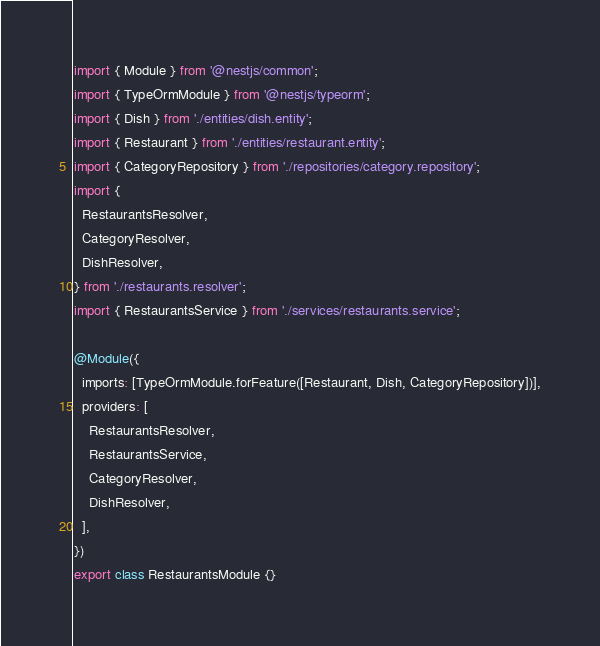<code> <loc_0><loc_0><loc_500><loc_500><_TypeScript_>import { Module } from '@nestjs/common';
import { TypeOrmModule } from '@nestjs/typeorm';
import { Dish } from './entities/dish.entity';
import { Restaurant } from './entities/restaurant.entity';
import { CategoryRepository } from './repositories/category.repository';
import {
  RestaurantsResolver,
  CategoryResolver,
  DishResolver,
} from './restaurants.resolver';
import { RestaurantsService } from './services/restaurants.service';

@Module({
  imports: [TypeOrmModule.forFeature([Restaurant, Dish, CategoryRepository])],
  providers: [
    RestaurantsResolver,
    RestaurantsService,
    CategoryResolver,
    DishResolver,
  ],
})
export class RestaurantsModule {}
</code> 